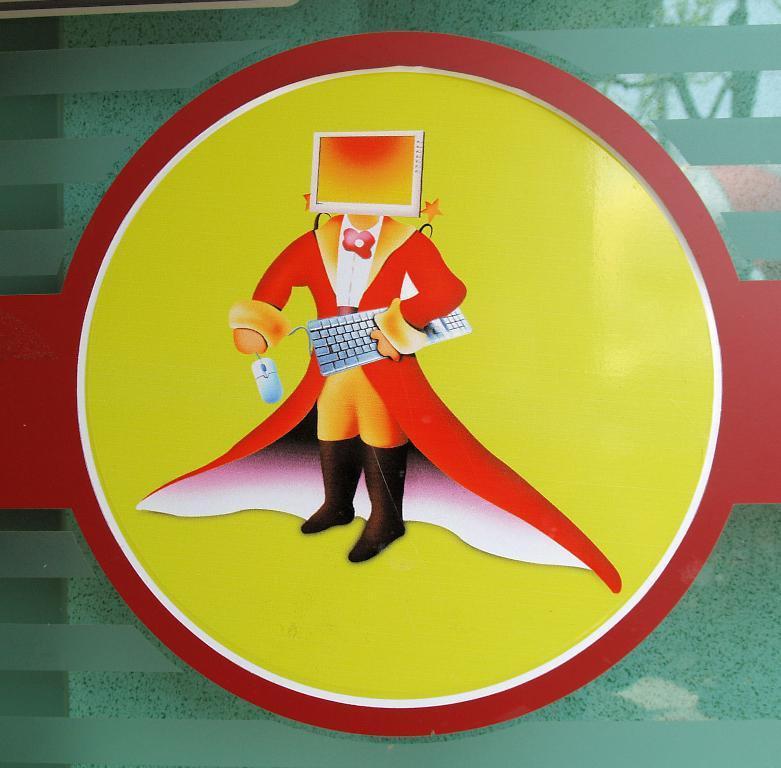Describe this image in one or two sentences. In this image I can see the toy person and the person is wearing red color dress and the background is in orange, red and green color and the person is holding a keyboard and a mouse. 